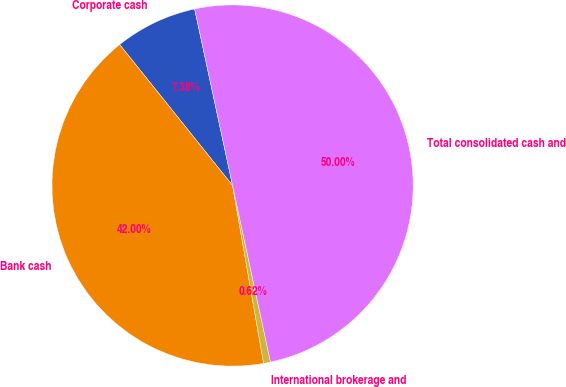Convert chart to OTSL. <chart><loc_0><loc_0><loc_500><loc_500><pie_chart><fcel>Corporate cash<fcel>Bank cash<fcel>International brokerage and<fcel>Total consolidated cash and<nl><fcel>7.38%<fcel>42.0%<fcel>0.62%<fcel>50.0%<nl></chart> 